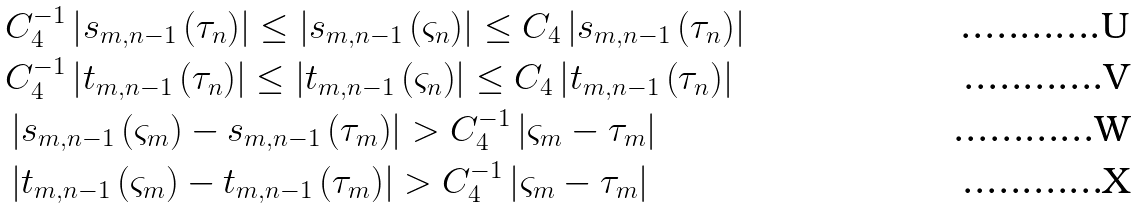Convert formula to latex. <formula><loc_0><loc_0><loc_500><loc_500>& C _ { 4 } ^ { - 1 } \left | s _ { m , n - 1 } \left ( \tau _ { n } \right ) \right | \leq \left | s _ { m , n - 1 } \left ( \varsigma _ { n } \right ) \right | \leq C _ { 4 } \left | s _ { m , n - 1 } \left ( \tau _ { n } \right ) \right | \\ & C _ { 4 } ^ { - 1 } \left | t _ { m , n - 1 } \left ( \tau _ { n } \right ) \right | \leq \left | t _ { m , n - 1 } \left ( \varsigma _ { n } \right ) \right | \leq C _ { 4 } \left | t _ { m , n - 1 } \left ( \tau _ { n } \right ) \right | \\ & \left | s _ { m , n - 1 } \left ( \varsigma _ { m } \right ) - s _ { m , n - 1 } \left ( \tau _ { m } \right ) \right | > C _ { 4 } ^ { - 1 } \left | \varsigma _ { m } - \tau _ { m } \right | \\ & \left | t _ { m , n - 1 } \left ( \varsigma _ { m } \right ) - t _ { m , n - 1 } \left ( \tau _ { m } \right ) \right | > C _ { 4 } ^ { - 1 } \left | \varsigma _ { m } - \tau _ { m } \right |</formula> 